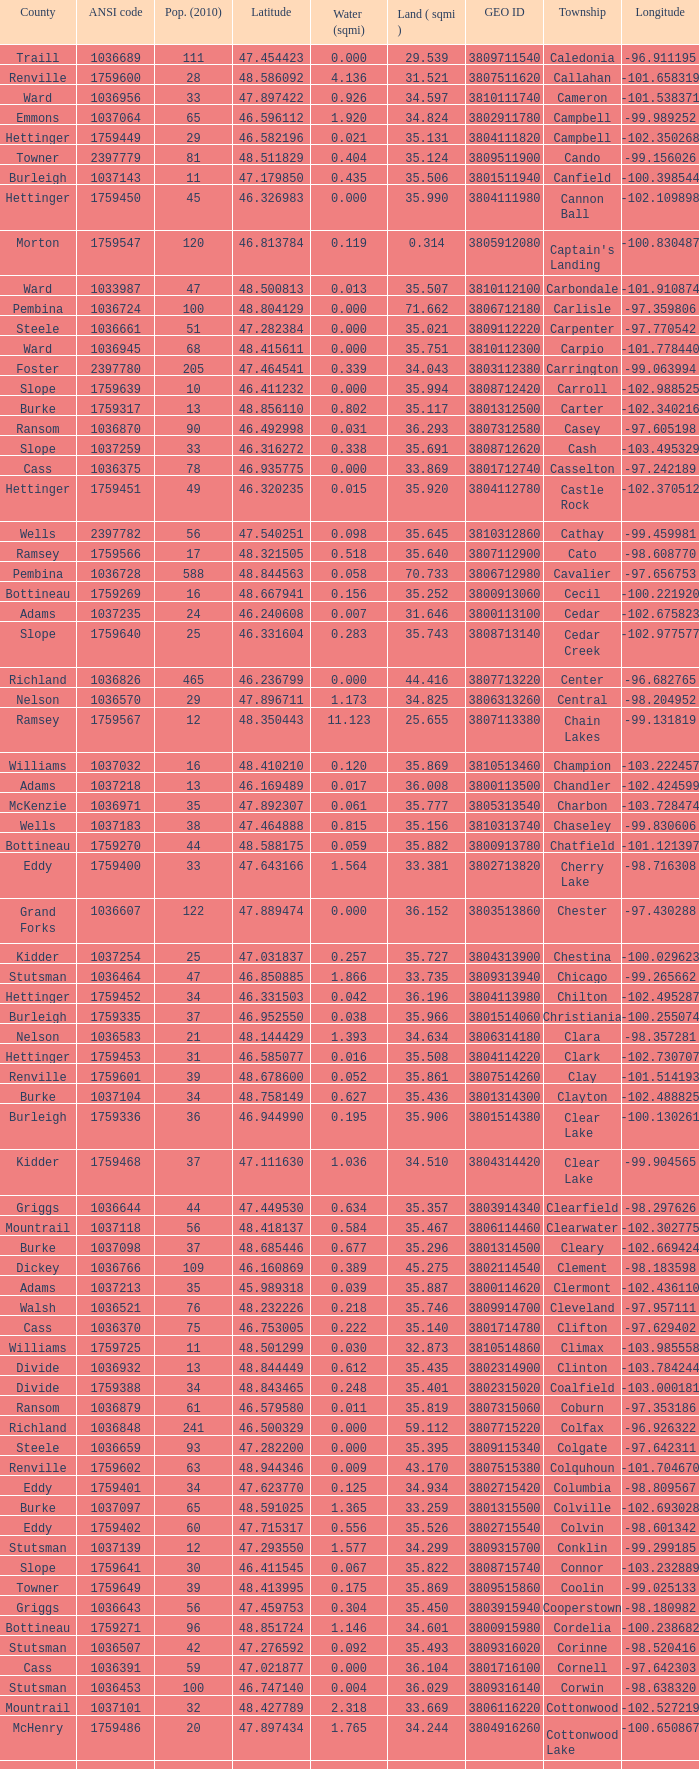Could you parse the entire table? {'header': ['County', 'ANSI code', 'Pop. (2010)', 'Latitude', 'Water (sqmi)', 'Land ( sqmi )', 'GEO ID', 'Township', 'Longitude'], 'rows': [['Traill', '1036689', '111', '47.454423', '0.000', '29.539', '3809711540', 'Caledonia', '-96.911195'], ['Renville', '1759600', '28', '48.586092', '4.136', '31.521', '3807511620', 'Callahan', '-101.658319'], ['Ward', '1036956', '33', '47.897422', '0.926', '34.597', '3810111740', 'Cameron', '-101.538371'], ['Emmons', '1037064', '65', '46.596112', '1.920', '34.824', '3802911780', 'Campbell', '-99.989252'], ['Hettinger', '1759449', '29', '46.582196', '0.021', '35.131', '3804111820', 'Campbell', '-102.350268'], ['Towner', '2397779', '81', '48.511829', '0.404', '35.124', '3809511900', 'Cando', '-99.156026'], ['Burleigh', '1037143', '11', '47.179850', '0.435', '35.506', '3801511940', 'Canfield', '-100.398544'], ['Hettinger', '1759450', '45', '46.326983', '0.000', '35.990', '3804111980', 'Cannon Ball', '-102.109898'], ['Morton', '1759547', '120', '46.813784', '0.119', '0.314', '3805912080', "Captain's Landing", '-100.830487'], ['Ward', '1033987', '47', '48.500813', '0.013', '35.507', '3810112100', 'Carbondale', '-101.910874'], ['Pembina', '1036724', '100', '48.804129', '0.000', '71.662', '3806712180', 'Carlisle', '-97.359806'], ['Steele', '1036661', '51', '47.282384', '0.000', '35.021', '3809112220', 'Carpenter', '-97.770542'], ['Ward', '1036945', '68', '48.415611', '0.000', '35.751', '3810112300', 'Carpio', '-101.778440'], ['Foster', '2397780', '205', '47.464541', '0.339', '34.043', '3803112380', 'Carrington', '-99.063994'], ['Slope', '1759639', '10', '46.411232', '0.000', '35.994', '3808712420', 'Carroll', '-102.988525'], ['Burke', '1759317', '13', '48.856110', '0.802', '35.117', '3801312500', 'Carter', '-102.340216'], ['Ransom', '1036870', '90', '46.492998', '0.031', '36.293', '3807312580', 'Casey', '-97.605198'], ['Slope', '1037259', '33', '46.316272', '0.338', '35.691', '3808712620', 'Cash', '-103.495329'], ['Cass', '1036375', '78', '46.935775', '0.000', '33.869', '3801712740', 'Casselton', '-97.242189'], ['Hettinger', '1759451', '49', '46.320235', '0.015', '35.920', '3804112780', 'Castle Rock', '-102.370512'], ['Wells', '2397782', '56', '47.540251', '0.098', '35.645', '3810312860', 'Cathay', '-99.459981'], ['Ramsey', '1759566', '17', '48.321505', '0.518', '35.640', '3807112900', 'Cato', '-98.608770'], ['Pembina', '1036728', '588', '48.844563', '0.058', '70.733', '3806712980', 'Cavalier', '-97.656753'], ['Bottineau', '1759269', '16', '48.667941', '0.156', '35.252', '3800913060', 'Cecil', '-100.221920'], ['Adams', '1037235', '24', '46.240608', '0.007', '31.646', '3800113100', 'Cedar', '-102.675823'], ['Slope', '1759640', '25', '46.331604', '0.283', '35.743', '3808713140', 'Cedar Creek', '-102.977577'], ['Richland', '1036826', '465', '46.236799', '0.000', '44.416', '3807713220', 'Center', '-96.682765'], ['Nelson', '1036570', '29', '47.896711', '1.173', '34.825', '3806313260', 'Central', '-98.204952'], ['Ramsey', '1759567', '12', '48.350443', '11.123', '25.655', '3807113380', 'Chain Lakes', '-99.131819'], ['Williams', '1037032', '16', '48.410210', '0.120', '35.869', '3810513460', 'Champion', '-103.222457'], ['Adams', '1037218', '13', '46.169489', '0.017', '36.008', '3800113500', 'Chandler', '-102.424599'], ['McKenzie', '1036971', '35', '47.892307', '0.061', '35.777', '3805313540', 'Charbon', '-103.728474'], ['Wells', '1037183', '38', '47.464888', '0.815', '35.156', '3810313740', 'Chaseley', '-99.830606'], ['Bottineau', '1759270', '44', '48.588175', '0.059', '35.882', '3800913780', 'Chatfield', '-101.121397'], ['Eddy', '1759400', '33', '47.643166', '1.564', '33.381', '3802713820', 'Cherry Lake', '-98.716308'], ['Grand Forks', '1036607', '122', '47.889474', '0.000', '36.152', '3803513860', 'Chester', '-97.430288'], ['Kidder', '1037254', '25', '47.031837', '0.257', '35.727', '3804313900', 'Chestina', '-100.029623'], ['Stutsman', '1036464', '47', '46.850885', '1.866', '33.735', '3809313940', 'Chicago', '-99.265662'], ['Hettinger', '1759452', '34', '46.331503', '0.042', '36.196', '3804113980', 'Chilton', '-102.495287'], ['Burleigh', '1759335', '37', '46.952550', '0.038', '35.966', '3801514060', 'Christiania', '-100.255074'], ['Nelson', '1036583', '21', '48.144429', '1.393', '34.634', '3806314180', 'Clara', '-98.357281'], ['Hettinger', '1759453', '31', '46.585077', '0.016', '35.508', '3804114220', 'Clark', '-102.730707'], ['Renville', '1759601', '39', '48.678600', '0.052', '35.861', '3807514260', 'Clay', '-101.514193'], ['Burke', '1037104', '34', '48.758149', '0.627', '35.436', '3801314300', 'Clayton', '-102.488825'], ['Burleigh', '1759336', '36', '46.944990', '0.195', '35.906', '3801514380', 'Clear Lake', '-100.130261'], ['Kidder', '1759468', '37', '47.111630', '1.036', '34.510', '3804314420', 'Clear Lake', '-99.904565'], ['Griggs', '1036644', '44', '47.449530', '0.634', '35.357', '3803914340', 'Clearfield', '-98.297626'], ['Mountrail', '1037118', '56', '48.418137', '0.584', '35.467', '3806114460', 'Clearwater', '-102.302775'], ['Burke', '1037098', '37', '48.685446', '0.677', '35.296', '3801314500', 'Cleary', '-102.669424'], ['Dickey', '1036766', '109', '46.160869', '0.389', '45.275', '3802114540', 'Clement', '-98.183598'], ['Adams', '1037213', '35', '45.989318', '0.039', '35.887', '3800114620', 'Clermont', '-102.436110'], ['Walsh', '1036521', '76', '48.232226', '0.218', '35.746', '3809914700', 'Cleveland', '-97.957111'], ['Cass', '1036370', '75', '46.753005', '0.222', '35.140', '3801714780', 'Clifton', '-97.629402'], ['Williams', '1759725', '11', '48.501299', '0.030', '32.873', '3810514860', 'Climax', '-103.985558'], ['Divide', '1036932', '13', '48.844449', '0.612', '35.435', '3802314900', 'Clinton', '-103.784244'], ['Divide', '1759388', '34', '48.843465', '0.248', '35.401', '3802315020', 'Coalfield', '-103.000181'], ['Ransom', '1036879', '61', '46.579580', '0.011', '35.819', '3807315060', 'Coburn', '-97.353186'], ['Richland', '1036848', '241', '46.500329', '0.000', '59.112', '3807715220', 'Colfax', '-96.926322'], ['Steele', '1036659', '93', '47.282200', '0.000', '35.395', '3809115340', 'Colgate', '-97.642311'], ['Renville', '1759602', '63', '48.944346', '0.009', '43.170', '3807515380', 'Colquhoun', '-101.704670'], ['Eddy', '1759401', '34', '47.623770', '0.125', '34.934', '3802715420', 'Columbia', '-98.809567'], ['Burke', '1037097', '65', '48.591025', '1.365', '33.259', '3801315500', 'Colville', '-102.693028'], ['Eddy', '1759402', '60', '47.715317', '0.556', '35.526', '3802715540', 'Colvin', '-98.601342'], ['Stutsman', '1037139', '12', '47.293550', '1.577', '34.299', '3809315700', 'Conklin', '-99.299185'], ['Slope', '1759641', '30', '46.411545', '0.067', '35.822', '3808715740', 'Connor', '-103.232889'], ['Towner', '1759649', '39', '48.413995', '0.175', '35.869', '3809515860', 'Coolin', '-99.025133'], ['Griggs', '1036643', '56', '47.459753', '0.304', '35.450', '3803915940', 'Cooperstown', '-98.180982'], ['Bottineau', '1759271', '96', '48.851724', '1.146', '34.601', '3800915980', 'Cordelia', '-100.238682'], ['Stutsman', '1036507', '42', '47.276592', '0.092', '35.493', '3809316020', 'Corinne', '-98.520416'], ['Cass', '1036391', '59', '47.021877', '0.000', '36.104', '3801716100', 'Cornell', '-97.642303'], ['Stutsman', '1036453', '100', '46.747140', '0.004', '36.029', '3809316140', 'Corwin', '-98.638320'], ['Mountrail', '1037101', '32', '48.427789', '2.318', '33.669', '3806116220', 'Cottonwood', '-102.527219'], ['McHenry', '1759486', '20', '47.897434', '1.765', '34.244', '3804916260', 'Cottonwood Lake', '-100.650867'], ['Ramsey', '1759568', '65', '48.235617', '0.216', '35.293', '3807116340', 'Coulee', '-99.126223'], ['Stutsman', '1036497', '36', '47.189672', '0.257', '35.235', '3809316420', 'Courtenay', '-98.530868'], ['Mountrail', '1037041', '84', '48.074507', '0.278', '35.704', '3806116540', 'Crane Creek', '-102.380242'], ['Slope', '1037166', '31', '46.320329', '0.051', '35.892', '3808716620', 'Crawford', '-103.729934'], ['Ramsey', '1759569', '1305', '48.075823', '15.621', '14.578', '3807116660', 'Creel', '-98.857272'], ['McLean', '1759530', '27', '47.811011', '0.054', '35.739', '3805516700', 'Cremerville', '-102.054883'], ['Towner', '1759650', '44', '48.667289', '0.940', '35.047', '3809516820', 'Crocus', '-99.155787'], ['Burleigh', '1037131', '199', '47.026425', '0.000', '36.163', '3801516860', 'Crofte', '-100.685988'], ['Burleigh', '1037133', '35', '47.026008', '0.000', '36.208', '3801516900', 'Cromwell', '-100.558805'], ['Mountrail', '1037050', '18', '48.495946', '1.283', '34.701', '3806116980', 'Crowfoot', '-102.180433'], ['Kidder', '1759469', '7', '46.770977', '1.468', '30.799', '3804317020', 'Crown Hill', '-100.025924'], ['Pembina', '1036718', '50', '48.586423', '0.000', '35.499', '3806717100', 'Crystal', '-97.732145'], ['Wells', '1037152', '32', '47.541346', '0.424', '35.522', '3810317140', 'Crystal Lake', '-99.974737'], ['Kidder', '1759470', '32', '46.848792', '0.636', '35.415', '3804317220', 'Crystal Springs', '-99.529639'], ['Barnes', '1036409', '76', '46.851144', '0.032', '35.709', '3800317300', 'Cuba', '-97.860271'], ['Stutsman', '1036459', '26', '46.746853', '0.693', '34.878', '3809317460', 'Cusator', '-98.997611'], ['Bottineau', '1759272', '37', '48.763937', '0.033', '35.898', '3800917540', 'Cut Bank', '-101.430571']]} What was the longitude of the township with a latitude of 48.075823? -98.857272. 